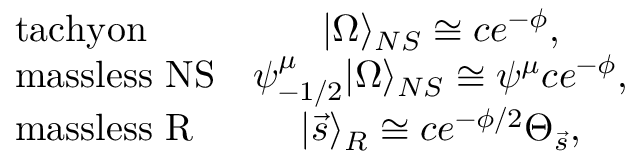<formula> <loc_0><loc_0><loc_500><loc_500>\begin{array} { l c } { t a c h y o n } & { { | \Omega \rangle _ { N S } \cong c e ^ { - \phi } , } } \\ { m a s s l e s s N S } & { { \psi _ { - 1 / 2 } ^ { \mu } | \Omega \rangle _ { N S } \cong \psi ^ { \mu } c e ^ { - \phi } , } } \\ { m a s s l e s s R } & { { | \vec { s } \rangle _ { R } \cong c e ^ { - \phi / 2 } \Theta _ { \vec { s } } , } } \end{array}</formula> 